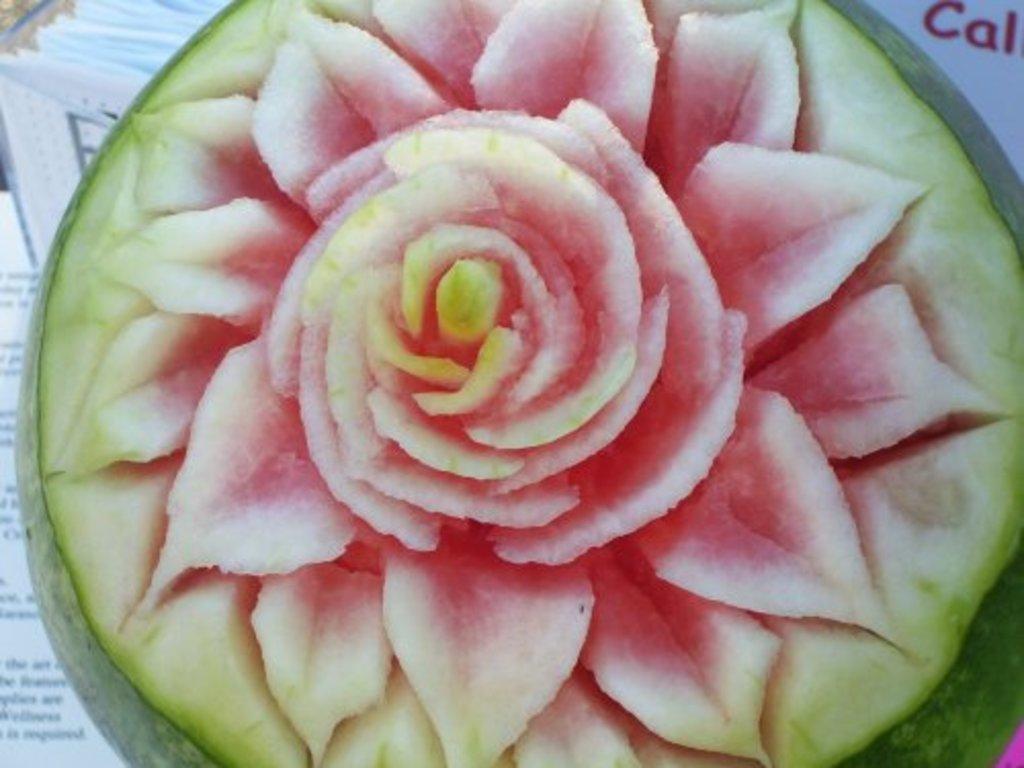How would you summarize this image in a sentence or two? Here we can see the design of a flower on the water melon. In the background on the left side we can see papers and an object. 